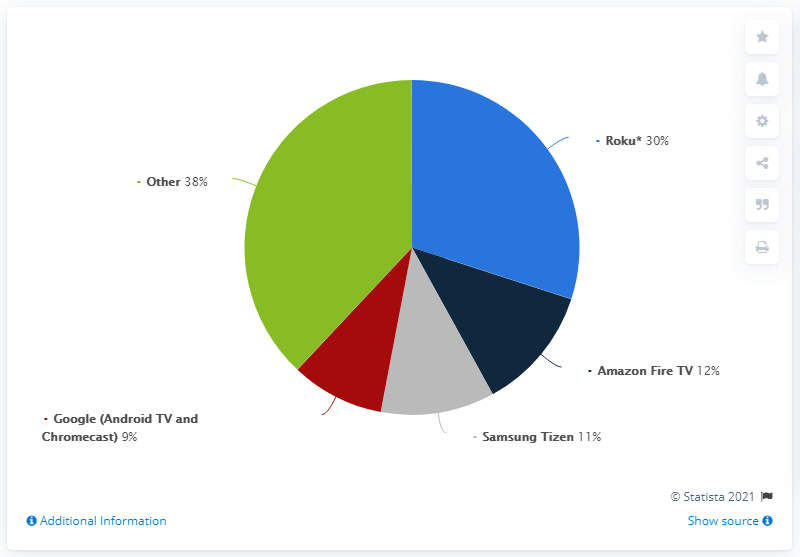Outline some significant characteristics in this image. The biggest slice of the pie represents the largest portion of a particular quantity or subject, while the smallest slice represents the smallest portion. For example, in a pie chart showing the distribution of a particular resource, the biggest slice would represent the largest share of that resource, while the smallest slice would represent the smallest share. The biggest slice of the pie is 38... According to data, Roku media streamers accounted for approximately 30% of all connected TV device sales in the United States in a given year. 